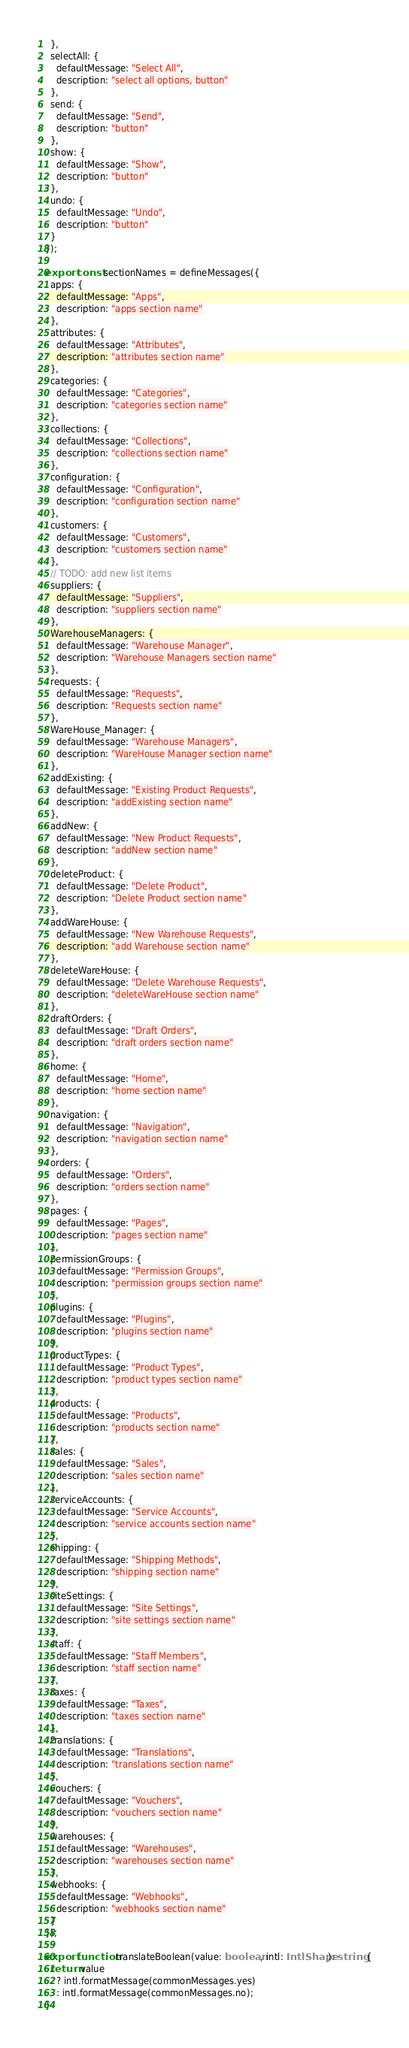Convert code to text. <code><loc_0><loc_0><loc_500><loc_500><_TypeScript_>  },
  selectAll: {
    defaultMessage: "Select All",
    description: "select all options, button"
  },
  send: {
    defaultMessage: "Send",
    description: "button"
  },
  show: {
    defaultMessage: "Show",
    description: "button"
  },
  undo: {
    defaultMessage: "Undo",
    description: "button"
  }
});

export const sectionNames = defineMessages({
  apps: {
    defaultMessage: "Apps",
    description: "apps section name"
  },
  attributes: {
    defaultMessage: "Attributes",
    description: "attributes section name"
  },
  categories: {
    defaultMessage: "Categories",
    description: "categories section name"
  },
  collections: {
    defaultMessage: "Collections",
    description: "collections section name"
  },
  configuration: {
    defaultMessage: "Configuration",
    description: "configuration section name"
  },
  customers: {
    defaultMessage: "Customers",
    description: "customers section name"
  },
  // TODO: add new list items
  suppliers: {
    defaultMessage: "Suppliers",
    description: "suppliers section name"
  },
  WarehouseManagers: {
    defaultMessage: "Warehouse Manager",
    description: "Warehouse Managers section name"
  },
  requests: {
    defaultMessage: "Requests",
    description: "Requests section name"
  },
  WareHouse_Manager: {
    defaultMessage: "Warehouse Managers",
    description: "WareHouse Manager section name"
  },
  addExisting: {
    defaultMessage: "Existing Product Requests",
    description: "addExisting section name"
  },
  addNew: {
    defaultMessage: "New Product Requests",
    description: "addNew section name"
  },
  deleteProduct: {
    defaultMessage: "Delete Product",
    description: "Delete Product section name"
  },
  addWareHouse: {
    defaultMessage: "New Warehouse Requests",
    description: "add Warehouse section name"
  },
  deleteWareHouse: {
    defaultMessage: "Delete Warehouse Requests",
    description: "deleteWareHouse section name"
  },
  draftOrders: {
    defaultMessage: "Draft Orders",
    description: "draft orders section name"
  },
  home: {
    defaultMessage: "Home",
    description: "home section name"
  },
  navigation: {
    defaultMessage: "Navigation",
    description: "navigation section name"
  },
  orders: {
    defaultMessage: "Orders",
    description: "orders section name"
  },
  pages: {
    defaultMessage: "Pages",
    description: "pages section name"
  },
  permissionGroups: {
    defaultMessage: "Permission Groups",
    description: "permission groups section name"
  },
  plugins: {
    defaultMessage: "Plugins",
    description: "plugins section name"
  },
  productTypes: {
    defaultMessage: "Product Types",
    description: "product types section name"
  },
  products: {
    defaultMessage: "Products",
    description: "products section name"
  },
  sales: {
    defaultMessage: "Sales",
    description: "sales section name"
  },
  serviceAccounts: {
    defaultMessage: "Service Accounts",
    description: "service accounts section name"
  },
  shipping: {
    defaultMessage: "Shipping Methods",
    description: "shipping section name"
  },
  siteSettings: {
    defaultMessage: "Site Settings",
    description: "site settings section name"
  },
  staff: {
    defaultMessage: "Staff Members",
    description: "staff section name"
  },
  taxes: {
    defaultMessage: "Taxes",
    description: "taxes section name"
  },
  translations: {
    defaultMessage: "Translations",
    description: "translations section name"
  },
  vouchers: {
    defaultMessage: "Vouchers",
    description: "vouchers section name"
  },
  warehouses: {
    defaultMessage: "Warehouses",
    description: "warehouses section name"
  },
  webhooks: {
    defaultMessage: "Webhooks",
    description: "webhooks section name"
  }
});

export function translateBoolean(value: boolean, intl: IntlShape): string {
  return value
    ? intl.formatMessage(commonMessages.yes)
    : intl.formatMessage(commonMessages.no);
}
</code> 